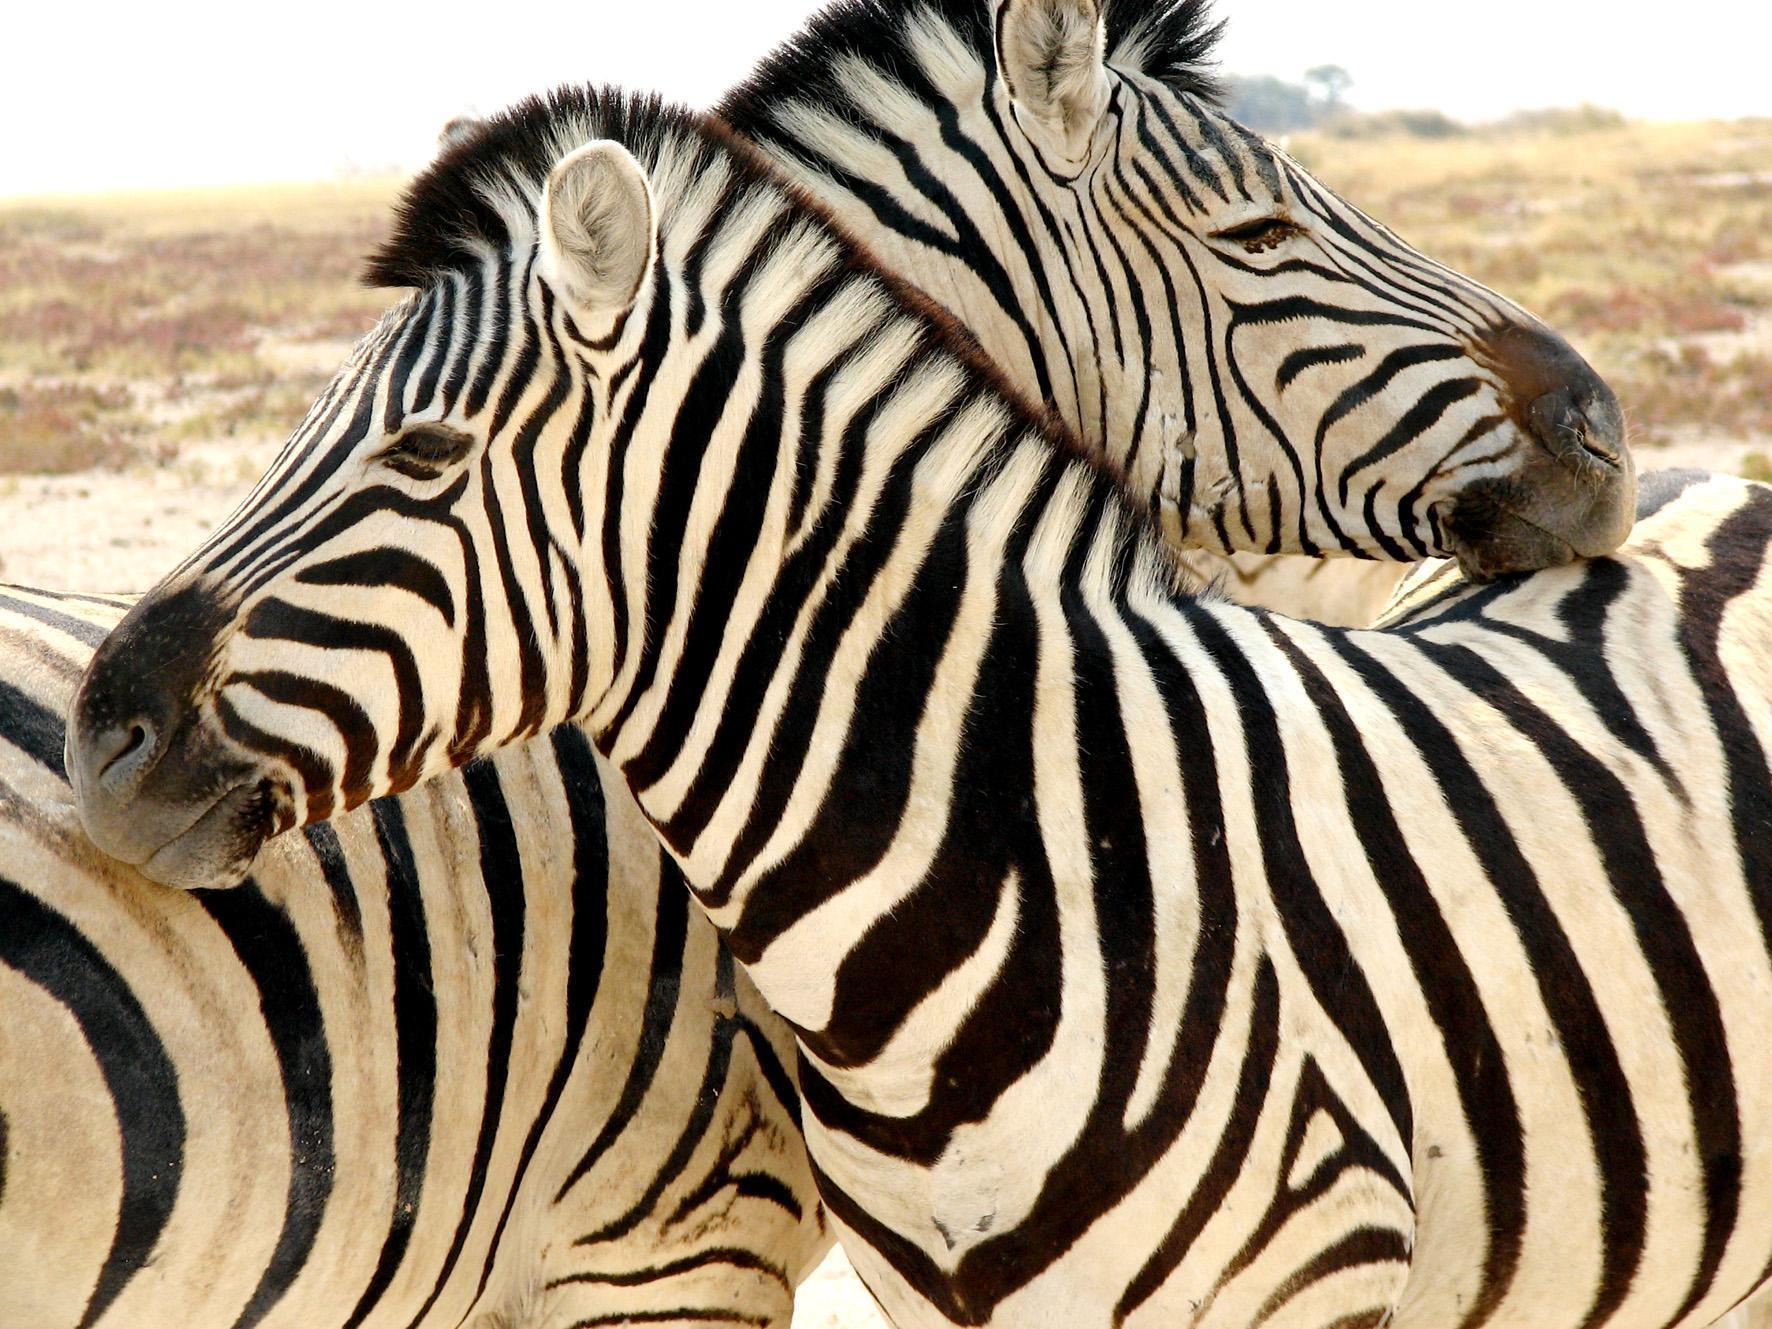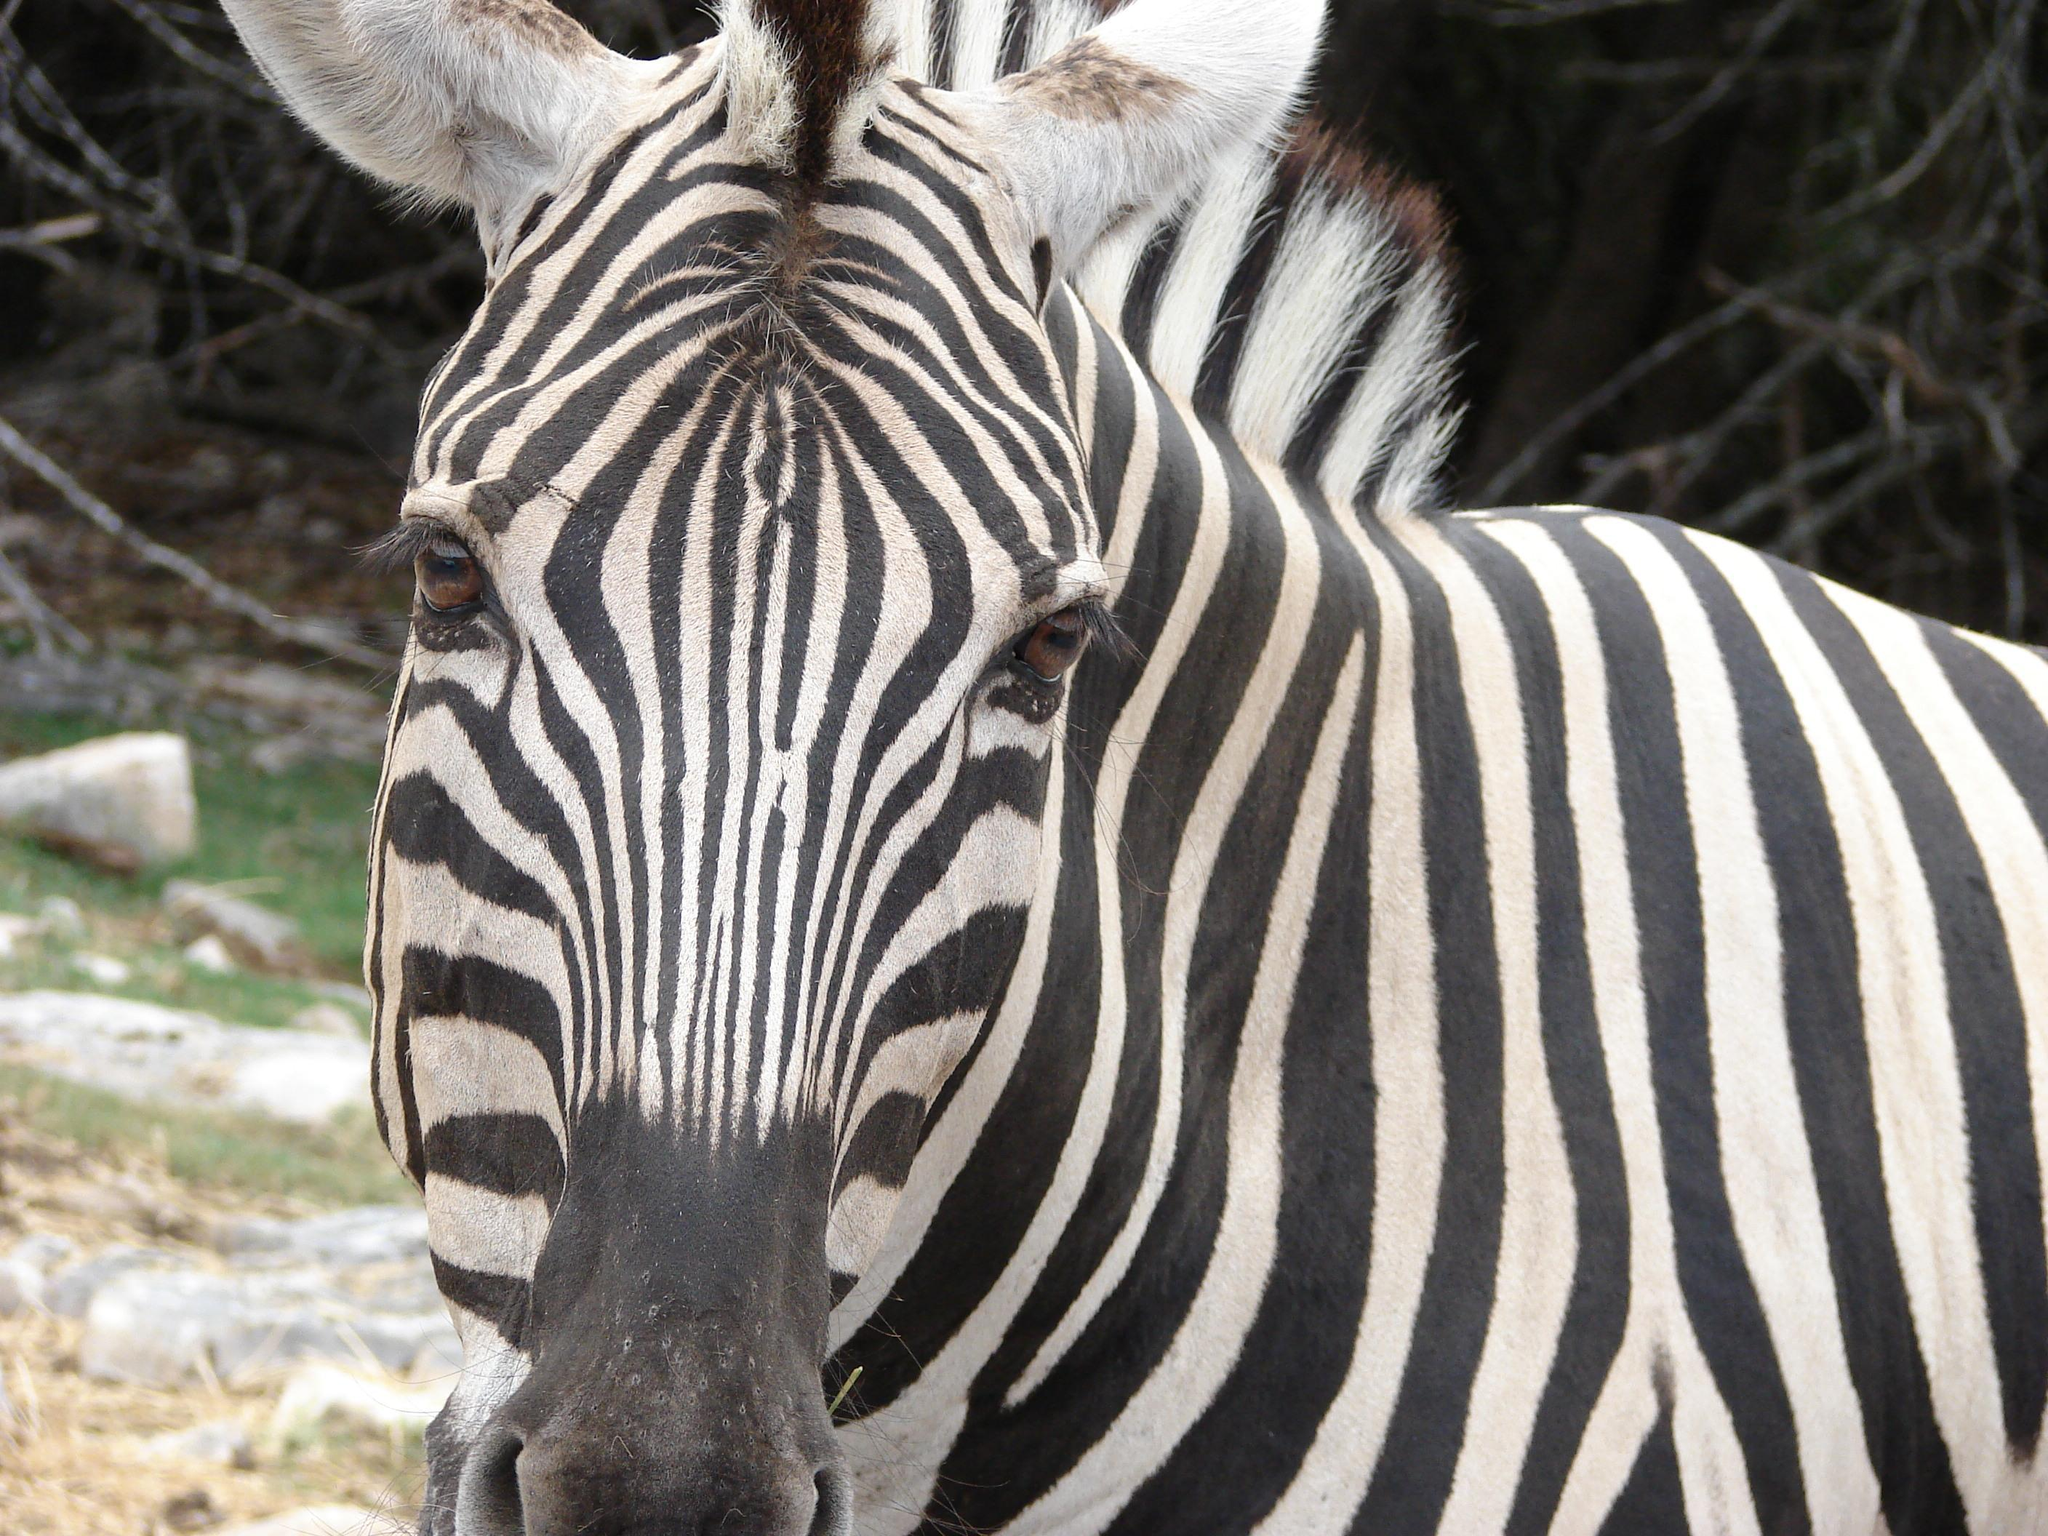The first image is the image on the left, the second image is the image on the right. Assess this claim about the two images: "In the left image two zebras are facing in opposite directions.". Correct or not? Answer yes or no. Yes. The first image is the image on the left, the second image is the image on the right. For the images shown, is this caption "Each image has two zebras and in only one of the images are they looking in the same direction." true? Answer yes or no. No. 